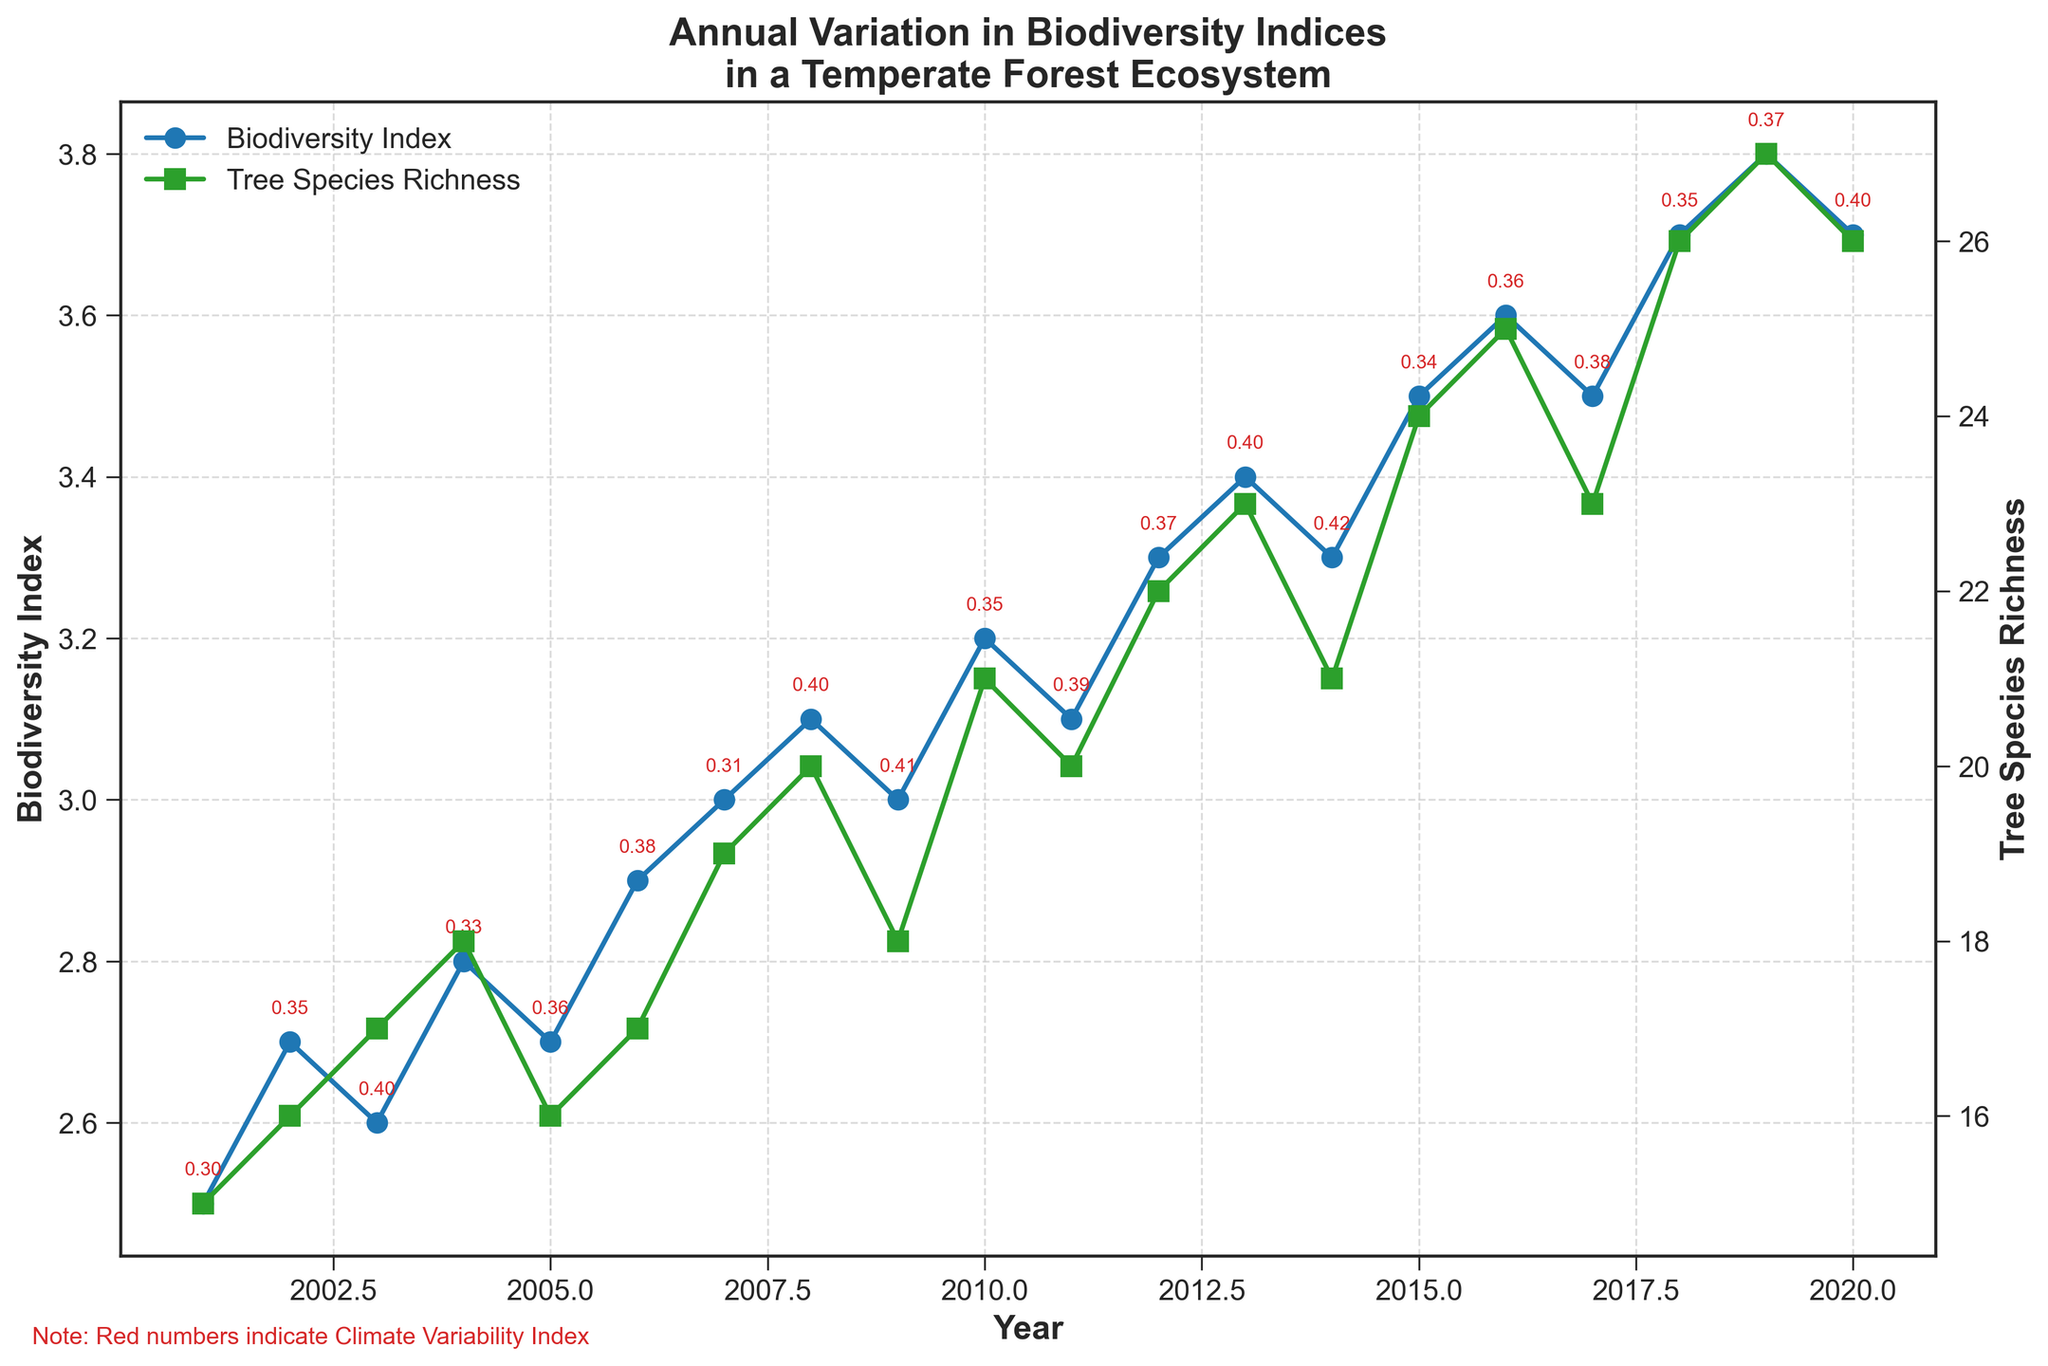what is the title of the figure? The title of the figure is located at the top and it provides an overview of what the plot represents. The title reads "Annual Variation in Biodiversity Indices in a Temperate Forest Ecosystem".
Answer: Annual Variation in Biodiversity Indices in a Temperate Forest Ecosystem Which axis represents the 'Biodiversity Index'? The y-axis on the left side of the plot (the primary y-axis) represents the 'Biodiversity Index'. This axis is labeled "Biodiversity Index".
Answer: Left y-axis How many years are represented in the plot? The x-axis represents the years from 2001 to 2020 inclusive. Counting these years gives a total of 20 years.
Answer: 20 years What's the highest value of 'Tree Species Richness' shown in the figure, and in which year does it occur? The highest value of 'Tree Species Richness' is clearly visible as it peaks at 27 in the year 2019.
Answer: 27 in 2019 Compare the 'Biodiversity Index' and 'Tree Species Richness' trends from 2001 to 2020. The 'Biodiversity Index' and 'Tree Species Richness' both show an upward trend from 2001 to 2020, but with some fluctuations. For example, the 'Biodiversity Index' slightly decreased in 2009 and 2017, whereas 'Tree Species Richness' had a peak in 2019.
Answer: Both show an upward trend with some fluctuations Which year shows the maximum 'Biodiversity Index' value, and what is the corresponding 'Tree Species Richness'? The maximum 'Biodiversity Index' value is 3.8 in the year 2019. The corresponding 'Tree Species Richness' in 2019 is 27.
Answer: 2019, Tree Species Richness is 27 In which years does the 'Climate Variability Index' reach its highest value? The 'Climate Variability Index' can be seen from red annotations. It reaches its highest value, 0.42, in the year 2014.
Answer: 2014 What can you infer about the relationship between 'Biodiversity Index' and 'Climate Variability Index'? From the annotations, years with higher 'Climate Variability Index' do not always correspond to significant changes in the 'Biodiversity Index'. For instance, in 2014, the highest 'Climate Variability Index' does not correspond to the highest 'Biodiversity Index'.
Answer: No clear correlation Compare the 'Biodiversity Index' values between 2001 and 2020. The difference indicates overall trend. The 'Biodiversity Index' in 2001 is 2.5, and in 2020 it is 3.7. The difference (3.7 - 2.5) indicates an upward trend, demonstrating an increase over the years.
Answer: Increase by 1.2 What is the overall trend of the 'Tree Species Richness' from the beginning to the end of the period? The 'Tree Species Richness' starts at around 15 in 2001 and increases to approximately 26 in 2020, showing a general upward trend over the years.
Answer: Upward trend 